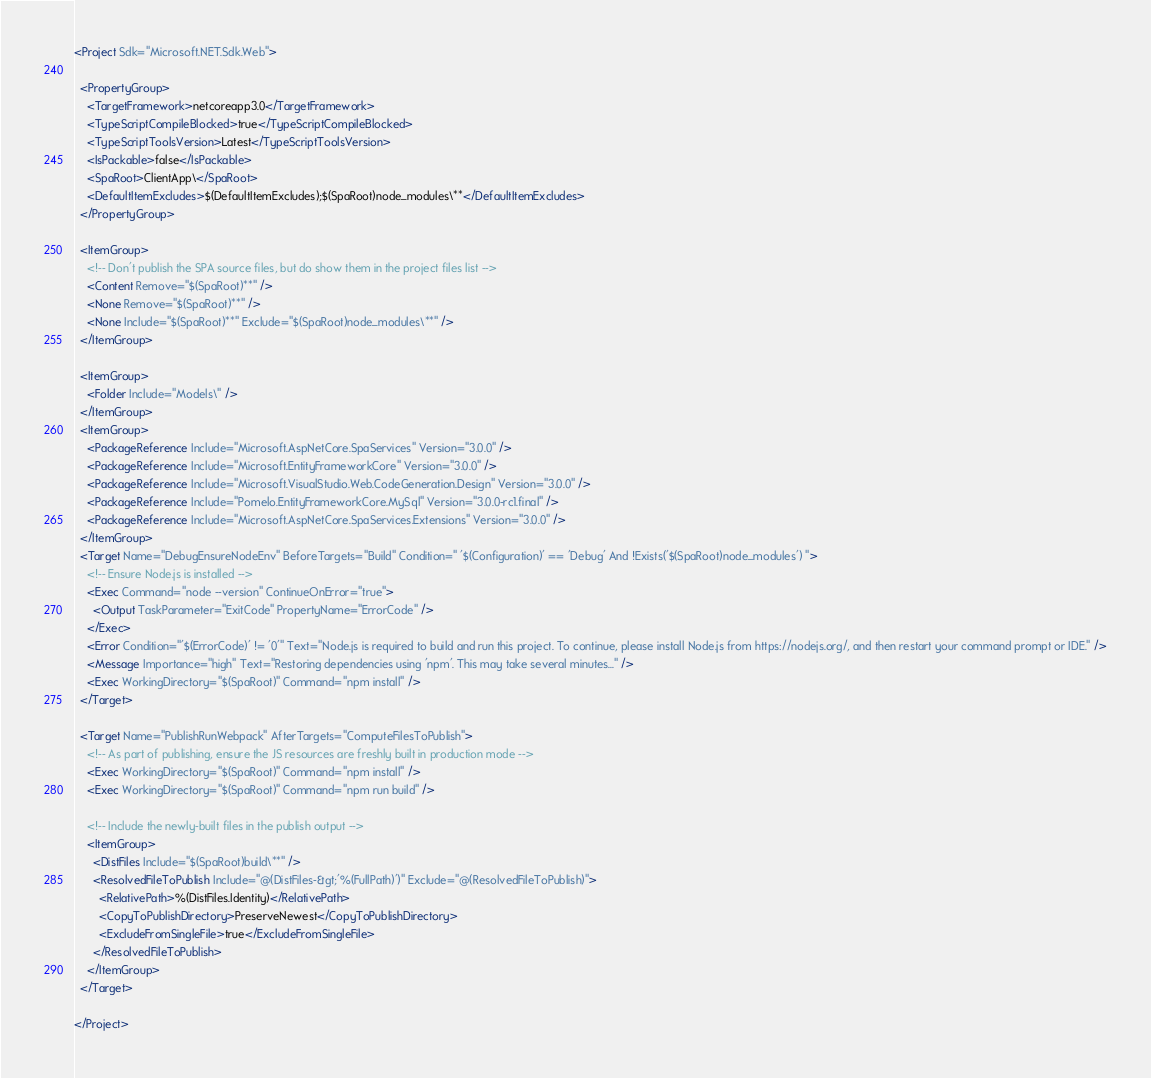Convert code to text. <code><loc_0><loc_0><loc_500><loc_500><_XML_><Project Sdk="Microsoft.NET.Sdk.Web">

  <PropertyGroup>
    <TargetFramework>netcoreapp3.0</TargetFramework>
    <TypeScriptCompileBlocked>true</TypeScriptCompileBlocked>
    <TypeScriptToolsVersion>Latest</TypeScriptToolsVersion>
    <IsPackable>false</IsPackable>
    <SpaRoot>ClientApp\</SpaRoot>
    <DefaultItemExcludes>$(DefaultItemExcludes);$(SpaRoot)node_modules\**</DefaultItemExcludes>
  </PropertyGroup>

  <ItemGroup>
    <!-- Don't publish the SPA source files, but do show them in the project files list -->
    <Content Remove="$(SpaRoot)**" />
    <None Remove="$(SpaRoot)**" />
    <None Include="$(SpaRoot)**" Exclude="$(SpaRoot)node_modules\**" />
  </ItemGroup>

  <ItemGroup>
    <Folder Include="Models\" />
  </ItemGroup>
  <ItemGroup>
    <PackageReference Include="Microsoft.AspNetCore.SpaServices" Version="3.0.0" />
    <PackageReference Include="Microsoft.EntityFrameworkCore" Version="3.0.0" />
    <PackageReference Include="Microsoft.VisualStudio.Web.CodeGeneration.Design" Version="3.0.0" />
    <PackageReference Include="Pomelo.EntityFrameworkCore.MySql" Version="3.0.0-rc1.final" />
    <PackageReference Include="Microsoft.AspNetCore.SpaServices.Extensions" Version="3.0.0" />
  </ItemGroup>
  <Target Name="DebugEnsureNodeEnv" BeforeTargets="Build" Condition=" '$(Configuration)' == 'Debug' And !Exists('$(SpaRoot)node_modules') ">
    <!-- Ensure Node.js is installed -->
    <Exec Command="node --version" ContinueOnError="true">
      <Output TaskParameter="ExitCode" PropertyName="ErrorCode" />
    </Exec>
    <Error Condition="'$(ErrorCode)' != '0'" Text="Node.js is required to build and run this project. To continue, please install Node.js from https://nodejs.org/, and then restart your command prompt or IDE." />
    <Message Importance="high" Text="Restoring dependencies using 'npm'. This may take several minutes..." />
    <Exec WorkingDirectory="$(SpaRoot)" Command="npm install" />
  </Target>

  <Target Name="PublishRunWebpack" AfterTargets="ComputeFilesToPublish">
    <!-- As part of publishing, ensure the JS resources are freshly built in production mode -->
    <Exec WorkingDirectory="$(SpaRoot)" Command="npm install" />
    <Exec WorkingDirectory="$(SpaRoot)" Command="npm run build" />

    <!-- Include the newly-built files in the publish output -->
    <ItemGroup>
      <DistFiles Include="$(SpaRoot)build\**" />
      <ResolvedFileToPublish Include="@(DistFiles-&gt;'%(FullPath)')" Exclude="@(ResolvedFileToPublish)">
        <RelativePath>%(DistFiles.Identity)</RelativePath>
        <CopyToPublishDirectory>PreserveNewest</CopyToPublishDirectory>
        <ExcludeFromSingleFile>true</ExcludeFromSingleFile>
      </ResolvedFileToPublish>
    </ItemGroup>
  </Target>

</Project>
</code> 